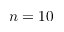Convert formula to latex. <formula><loc_0><loc_0><loc_500><loc_500>n = 1 0</formula> 